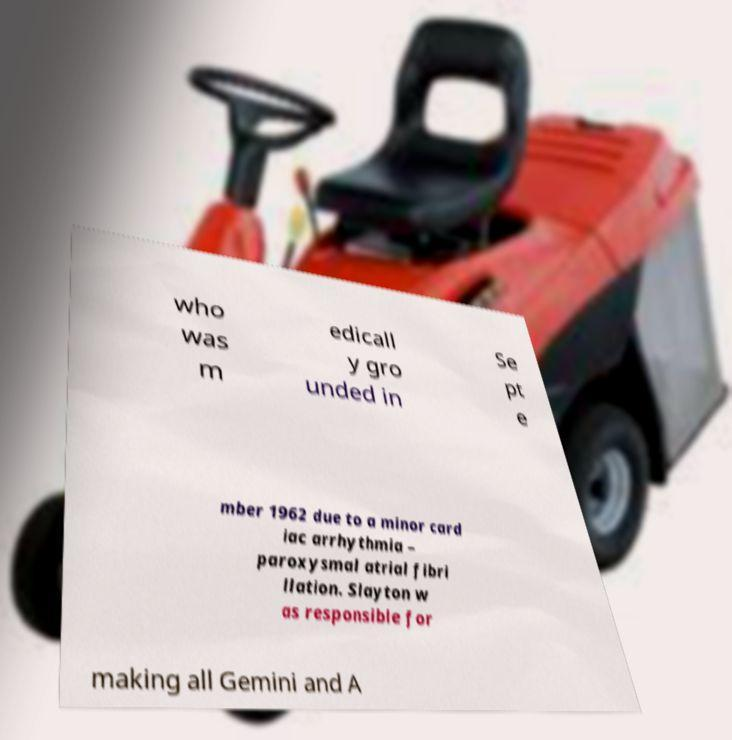Can you read and provide the text displayed in the image?This photo seems to have some interesting text. Can you extract and type it out for me? who was m edicall y gro unded in Se pt e mber 1962 due to a minor card iac arrhythmia – paroxysmal atrial fibri llation. Slayton w as responsible for making all Gemini and A 